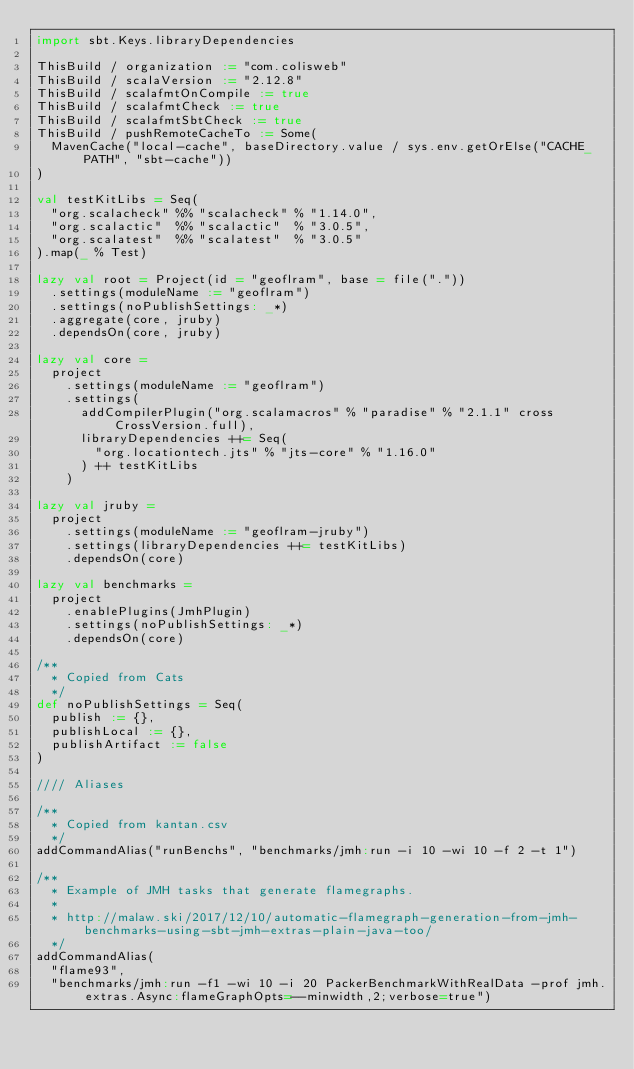Convert code to text. <code><loc_0><loc_0><loc_500><loc_500><_Scala_>import sbt.Keys.libraryDependencies

ThisBuild / organization := "com.colisweb"
ThisBuild / scalaVersion := "2.12.8"
ThisBuild / scalafmtOnCompile := true
ThisBuild / scalafmtCheck := true
ThisBuild / scalafmtSbtCheck := true
ThisBuild / pushRemoteCacheTo := Some(
  MavenCache("local-cache", baseDirectory.value / sys.env.getOrElse("CACHE_PATH", "sbt-cache"))
)

val testKitLibs = Seq(
  "org.scalacheck" %% "scalacheck" % "1.14.0",
  "org.scalactic"  %% "scalactic"  % "3.0.5",
  "org.scalatest"  %% "scalatest"  % "3.0.5"
).map(_ % Test)

lazy val root = Project(id = "geoflram", base = file("."))
  .settings(moduleName := "geoflram")
  .settings(noPublishSettings: _*)
  .aggregate(core, jruby)
  .dependsOn(core, jruby)

lazy val core =
  project
    .settings(moduleName := "geoflram")
    .settings(
      addCompilerPlugin("org.scalamacros" % "paradise" % "2.1.1" cross CrossVersion.full),
      libraryDependencies ++= Seq(
        "org.locationtech.jts" % "jts-core" % "1.16.0"
      ) ++ testKitLibs
    )

lazy val jruby =
  project
    .settings(moduleName := "geoflram-jruby")
    .settings(libraryDependencies ++= testKitLibs)
    .dependsOn(core)

lazy val benchmarks =
  project
    .enablePlugins(JmhPlugin)
    .settings(noPublishSettings: _*)
    .dependsOn(core)

/**
  * Copied from Cats
  */
def noPublishSettings = Seq(
  publish := {},
  publishLocal := {},
  publishArtifact := false
)

//// Aliases

/**
  * Copied from kantan.csv
  */
addCommandAlias("runBenchs", "benchmarks/jmh:run -i 10 -wi 10 -f 2 -t 1")

/**
  * Example of JMH tasks that generate flamegraphs.
  *
  * http://malaw.ski/2017/12/10/automatic-flamegraph-generation-from-jmh-benchmarks-using-sbt-jmh-extras-plain-java-too/
  */
addCommandAlias(
  "flame93",
  "benchmarks/jmh:run -f1 -wi 10 -i 20 PackerBenchmarkWithRealData -prof jmh.extras.Async:flameGraphOpts=--minwidth,2;verbose=true")
</code> 